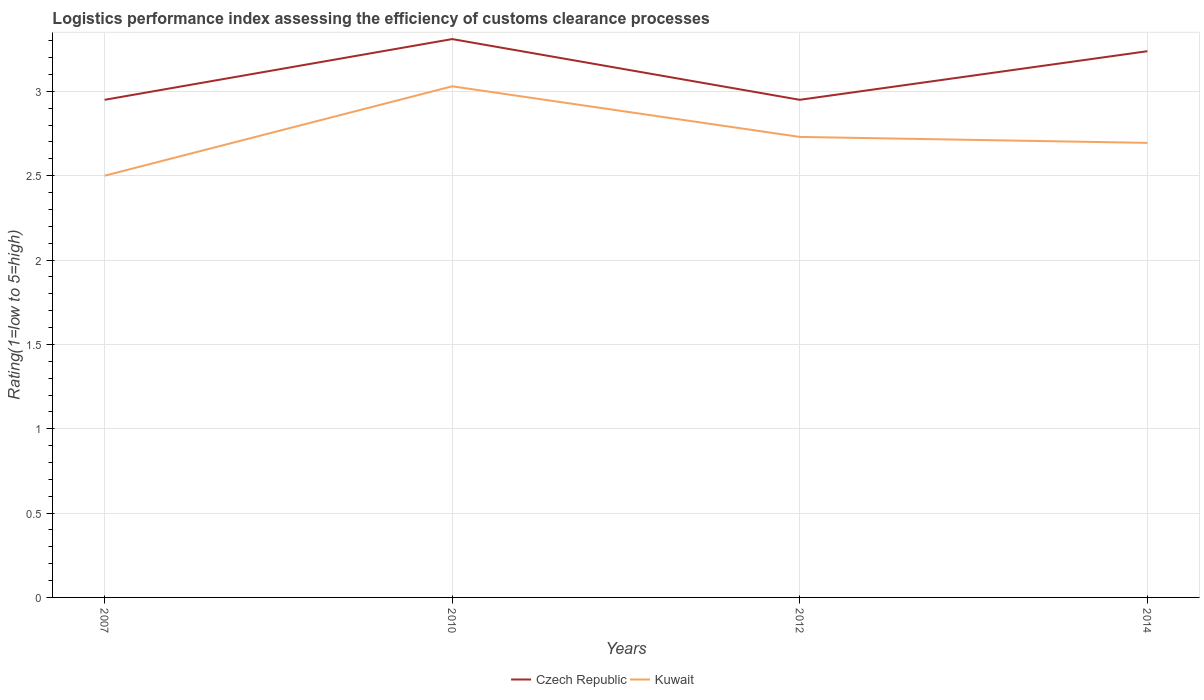How many different coloured lines are there?
Give a very brief answer. 2. In which year was the Logistic performance index in Czech Republic maximum?
Your answer should be very brief. 2007. What is the total Logistic performance index in Kuwait in the graph?
Provide a short and direct response. -0.53. What is the difference between the highest and the second highest Logistic performance index in Czech Republic?
Your response must be concise. 0.36. How many lines are there?
Give a very brief answer. 2. How many years are there in the graph?
Your response must be concise. 4. Does the graph contain any zero values?
Your answer should be compact. No. Does the graph contain grids?
Your answer should be compact. Yes. Where does the legend appear in the graph?
Provide a succinct answer. Bottom center. What is the title of the graph?
Offer a terse response. Logistics performance index assessing the efficiency of customs clearance processes. Does "Arab World" appear as one of the legend labels in the graph?
Provide a succinct answer. No. What is the label or title of the Y-axis?
Give a very brief answer. Rating(1=low to 5=high). What is the Rating(1=low to 5=high) of Czech Republic in 2007?
Your response must be concise. 2.95. What is the Rating(1=low to 5=high) of Czech Republic in 2010?
Offer a very short reply. 3.31. What is the Rating(1=low to 5=high) in Kuwait in 2010?
Offer a terse response. 3.03. What is the Rating(1=low to 5=high) of Czech Republic in 2012?
Your answer should be compact. 2.95. What is the Rating(1=low to 5=high) in Kuwait in 2012?
Ensure brevity in your answer.  2.73. What is the Rating(1=low to 5=high) in Czech Republic in 2014?
Make the answer very short. 3.24. What is the Rating(1=low to 5=high) in Kuwait in 2014?
Keep it short and to the point. 2.69. Across all years, what is the maximum Rating(1=low to 5=high) in Czech Republic?
Your response must be concise. 3.31. Across all years, what is the maximum Rating(1=low to 5=high) in Kuwait?
Keep it short and to the point. 3.03. Across all years, what is the minimum Rating(1=low to 5=high) in Czech Republic?
Offer a very short reply. 2.95. Across all years, what is the minimum Rating(1=low to 5=high) in Kuwait?
Your answer should be very brief. 2.5. What is the total Rating(1=low to 5=high) in Czech Republic in the graph?
Give a very brief answer. 12.45. What is the total Rating(1=low to 5=high) in Kuwait in the graph?
Keep it short and to the point. 10.95. What is the difference between the Rating(1=low to 5=high) of Czech Republic in 2007 and that in 2010?
Offer a terse response. -0.36. What is the difference between the Rating(1=low to 5=high) in Kuwait in 2007 and that in 2010?
Provide a succinct answer. -0.53. What is the difference between the Rating(1=low to 5=high) in Czech Republic in 2007 and that in 2012?
Provide a short and direct response. 0. What is the difference between the Rating(1=low to 5=high) in Kuwait in 2007 and that in 2012?
Provide a short and direct response. -0.23. What is the difference between the Rating(1=low to 5=high) of Czech Republic in 2007 and that in 2014?
Provide a short and direct response. -0.29. What is the difference between the Rating(1=low to 5=high) of Kuwait in 2007 and that in 2014?
Offer a very short reply. -0.19. What is the difference between the Rating(1=low to 5=high) of Czech Republic in 2010 and that in 2012?
Offer a terse response. 0.36. What is the difference between the Rating(1=low to 5=high) in Czech Republic in 2010 and that in 2014?
Make the answer very short. 0.07. What is the difference between the Rating(1=low to 5=high) in Kuwait in 2010 and that in 2014?
Ensure brevity in your answer.  0.34. What is the difference between the Rating(1=low to 5=high) in Czech Republic in 2012 and that in 2014?
Provide a short and direct response. -0.29. What is the difference between the Rating(1=low to 5=high) in Kuwait in 2012 and that in 2014?
Offer a terse response. 0.04. What is the difference between the Rating(1=low to 5=high) in Czech Republic in 2007 and the Rating(1=low to 5=high) in Kuwait in 2010?
Provide a short and direct response. -0.08. What is the difference between the Rating(1=low to 5=high) in Czech Republic in 2007 and the Rating(1=low to 5=high) in Kuwait in 2012?
Keep it short and to the point. 0.22. What is the difference between the Rating(1=low to 5=high) of Czech Republic in 2007 and the Rating(1=low to 5=high) of Kuwait in 2014?
Make the answer very short. 0.26. What is the difference between the Rating(1=low to 5=high) of Czech Republic in 2010 and the Rating(1=low to 5=high) of Kuwait in 2012?
Your response must be concise. 0.58. What is the difference between the Rating(1=low to 5=high) in Czech Republic in 2010 and the Rating(1=low to 5=high) in Kuwait in 2014?
Make the answer very short. 0.62. What is the difference between the Rating(1=low to 5=high) in Czech Republic in 2012 and the Rating(1=low to 5=high) in Kuwait in 2014?
Your response must be concise. 0.26. What is the average Rating(1=low to 5=high) of Czech Republic per year?
Ensure brevity in your answer.  3.11. What is the average Rating(1=low to 5=high) of Kuwait per year?
Give a very brief answer. 2.74. In the year 2007, what is the difference between the Rating(1=low to 5=high) in Czech Republic and Rating(1=low to 5=high) in Kuwait?
Ensure brevity in your answer.  0.45. In the year 2010, what is the difference between the Rating(1=low to 5=high) in Czech Republic and Rating(1=low to 5=high) in Kuwait?
Provide a short and direct response. 0.28. In the year 2012, what is the difference between the Rating(1=low to 5=high) in Czech Republic and Rating(1=low to 5=high) in Kuwait?
Provide a short and direct response. 0.22. In the year 2014, what is the difference between the Rating(1=low to 5=high) in Czech Republic and Rating(1=low to 5=high) in Kuwait?
Provide a short and direct response. 0.54. What is the ratio of the Rating(1=low to 5=high) in Czech Republic in 2007 to that in 2010?
Your response must be concise. 0.89. What is the ratio of the Rating(1=low to 5=high) in Kuwait in 2007 to that in 2010?
Your answer should be compact. 0.83. What is the ratio of the Rating(1=low to 5=high) in Czech Republic in 2007 to that in 2012?
Your answer should be compact. 1. What is the ratio of the Rating(1=low to 5=high) of Kuwait in 2007 to that in 2012?
Ensure brevity in your answer.  0.92. What is the ratio of the Rating(1=low to 5=high) in Czech Republic in 2007 to that in 2014?
Keep it short and to the point. 0.91. What is the ratio of the Rating(1=low to 5=high) of Kuwait in 2007 to that in 2014?
Your answer should be compact. 0.93. What is the ratio of the Rating(1=low to 5=high) of Czech Republic in 2010 to that in 2012?
Provide a short and direct response. 1.12. What is the ratio of the Rating(1=low to 5=high) of Kuwait in 2010 to that in 2012?
Keep it short and to the point. 1.11. What is the ratio of the Rating(1=low to 5=high) of Czech Republic in 2010 to that in 2014?
Provide a succinct answer. 1.02. What is the ratio of the Rating(1=low to 5=high) in Kuwait in 2010 to that in 2014?
Offer a terse response. 1.12. What is the ratio of the Rating(1=low to 5=high) in Czech Republic in 2012 to that in 2014?
Provide a succinct answer. 0.91. What is the ratio of the Rating(1=low to 5=high) of Kuwait in 2012 to that in 2014?
Offer a terse response. 1.01. What is the difference between the highest and the second highest Rating(1=low to 5=high) of Czech Republic?
Keep it short and to the point. 0.07. What is the difference between the highest and the lowest Rating(1=low to 5=high) of Czech Republic?
Your answer should be very brief. 0.36. What is the difference between the highest and the lowest Rating(1=low to 5=high) of Kuwait?
Provide a succinct answer. 0.53. 